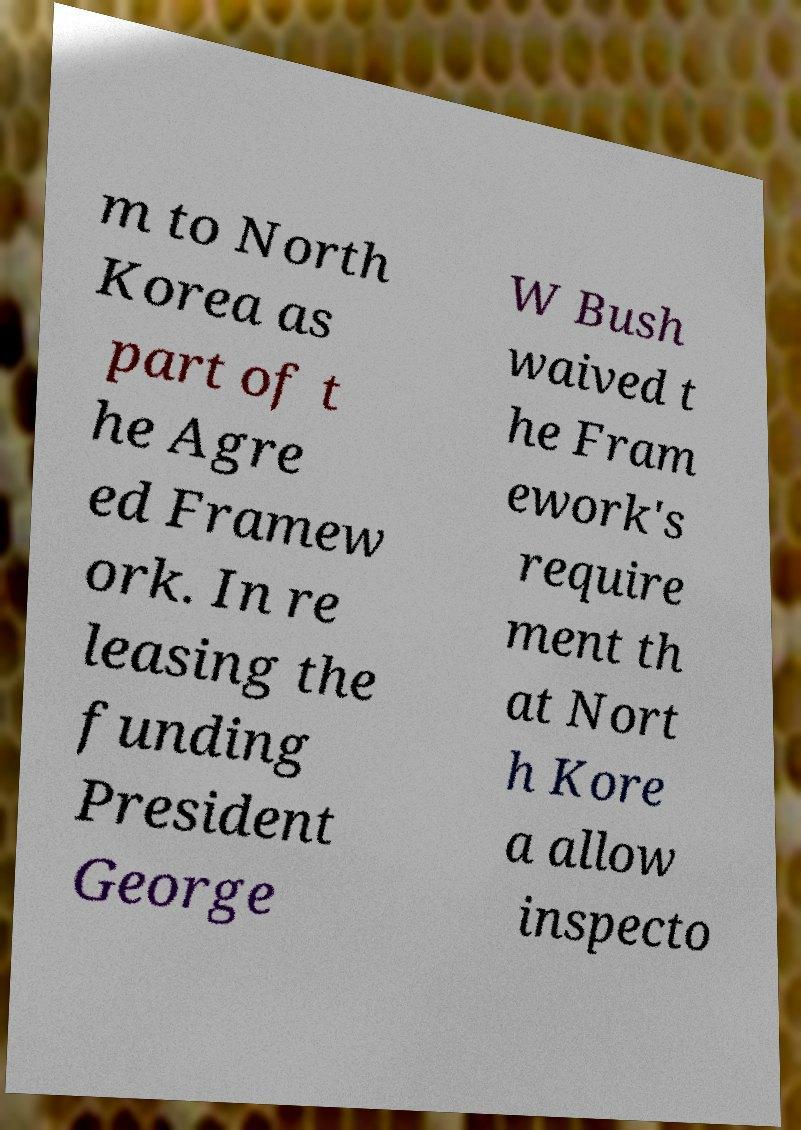Please read and relay the text visible in this image. What does it say? m to North Korea as part of t he Agre ed Framew ork. In re leasing the funding President George W Bush waived t he Fram ework's require ment th at Nort h Kore a allow inspecto 